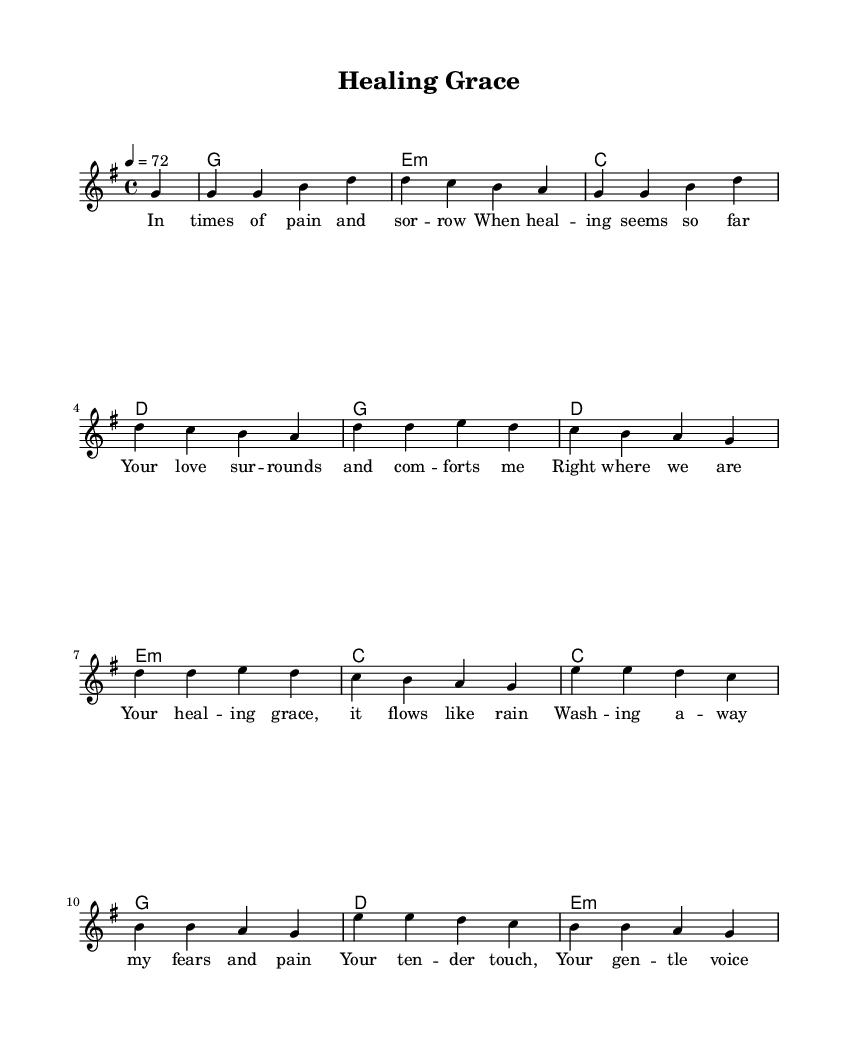What is the key signature of this music? The key signature is G major, which has one sharp (F#). This is indicated at the beginning of the sheet music.
Answer: G major What is the time signature of the piece? The time signature is 4/4, meaning there are four beats in each measure, and the quarter note gets one beat. This can be found listed explicitly in the music notation.
Answer: 4/4 What is the tempo marking for this music? The tempo marking is 72 beats per minute, which indicates how fast the piece should be played. This is shown at the beginning of the score.
Answer: 72 How many measures are there in the melody section? The melody consists of 8 measures in total, identifiable by counting the vertical bars separating the sections in the music.
Answer: 8 What is the emotional theme of the lyrics? The emotional theme is healing and comfort, as indicated by references to pain, love, and restoration throughout the lyrics. This can be analyzed by reading the lyric content closely.
Answer: Healing and comfort What are the primary chords used in the harmonies? The primary chords used are G major, E minor, C major, and D major, as indicated by the chord symbols above the staff throughout the piece.
Answer: G, E minor, C, D 